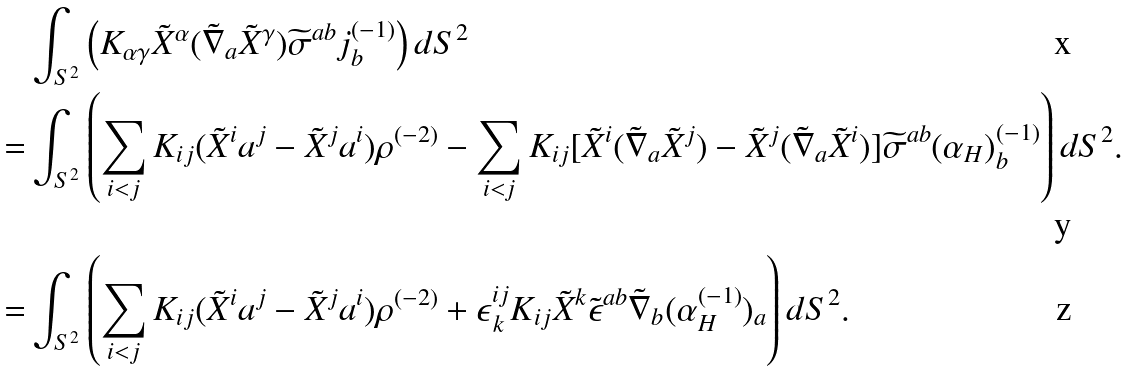<formula> <loc_0><loc_0><loc_500><loc_500>& \int _ { S ^ { 2 } } \left ( K _ { \alpha \gamma } \tilde { X } ^ { \alpha } ( \tilde { \nabla } _ { a } \tilde { X } ^ { \gamma } ) \widetilde { \sigma } ^ { a b } j ^ { ( - 1 ) } _ { b } \right ) d S ^ { 2 } \\ = & \int _ { S ^ { 2 } } \left ( \sum _ { i < j } K _ { i j } ( \tilde { X } ^ { i } a ^ { j } - \tilde { X } ^ { j } a ^ { i } ) \rho ^ { ( - 2 ) } - \sum _ { i < j } K _ { i j } [ \tilde { X } ^ { i } ( \tilde { \nabla } _ { a } \tilde { X } ^ { j } ) - \tilde { X } ^ { j } ( \tilde { \nabla } _ { a } \tilde { X } ^ { i } ) ] \widetilde { \sigma } ^ { a b } ( \alpha _ { H } ) _ { b } ^ { ( - 1 ) } \right ) d S ^ { 2 } . \\ = & \int _ { S ^ { 2 } } \left ( \sum _ { i < j } K _ { i j } ( \tilde { X } ^ { i } a ^ { j } - \tilde { X } ^ { j } a ^ { i } ) \rho ^ { ( - 2 ) } + \epsilon ^ { i j } _ { \, k } K _ { i j } \tilde { X } ^ { k } \tilde { \epsilon } ^ { a b } \tilde { \nabla } _ { b } ( \alpha _ { H } ^ { ( - 1 ) } ) _ { a } \right ) d S ^ { 2 } .</formula> 